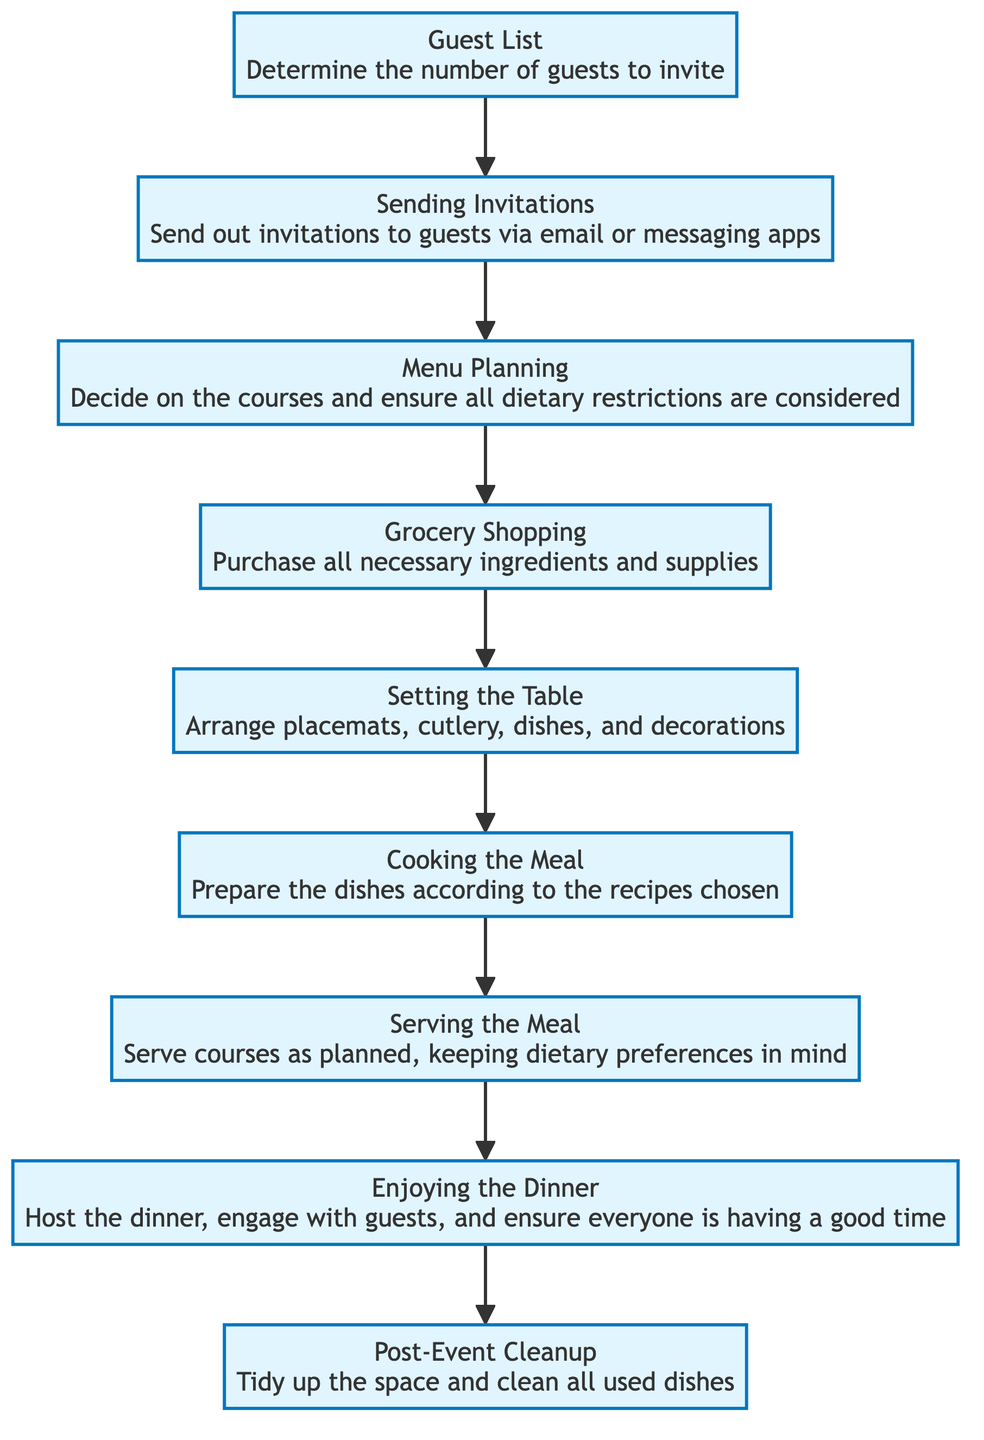What is the starting point of the flow? The flow begins from the "Guest List" node, which is where the process of hosting a dinner party starts.
Answer: Guest List How many nodes are there in the diagram? There are 8 nodes in the diagram, including the starting point and the endpoint.
Answer: 8 What is the last step before the "Post-Event Cleanup"? The last step before "Post-Event Cleanup" is "Enjoying the Dinner," where the host engages with guests.
Answer: Enjoying the Dinner Which step involves dietary preferences? "Serving the Meal" involves taking dietary preferences into account while serving courses.
Answer: Serving the Meal What is the relationship between "Grocery Shopping" and "Setting the Table"? "Grocery Shopping" is followed by "Setting the Table," meaning after shopping, the next action is to set the table.
Answer: Grocery Shopping → Setting the Table What is the second step in the flow? The second step in the flow after the "Guest List" is "Sending Invitations." This is where the host invites guests.
Answer: Sending Invitations Which activity comes immediately after "Cooking the Meal"? The activity that comes immediately after "Cooking the Meal" is "Serving the Meal." This indicates the order of activities during the dinner party.
Answer: Serving the Meal What does the "Menu Planning" step consider? The "Menu Planning" step considers all dietary restrictions while deciding on the courses.
Answer: Dietary restrictions What is the primary goal of the "Enjoying the Dinner" step? The primary goal of "Enjoying the Dinner" is to ensure that everyone is having a good time during the event.
Answer: Ensure everyone is having a good time 